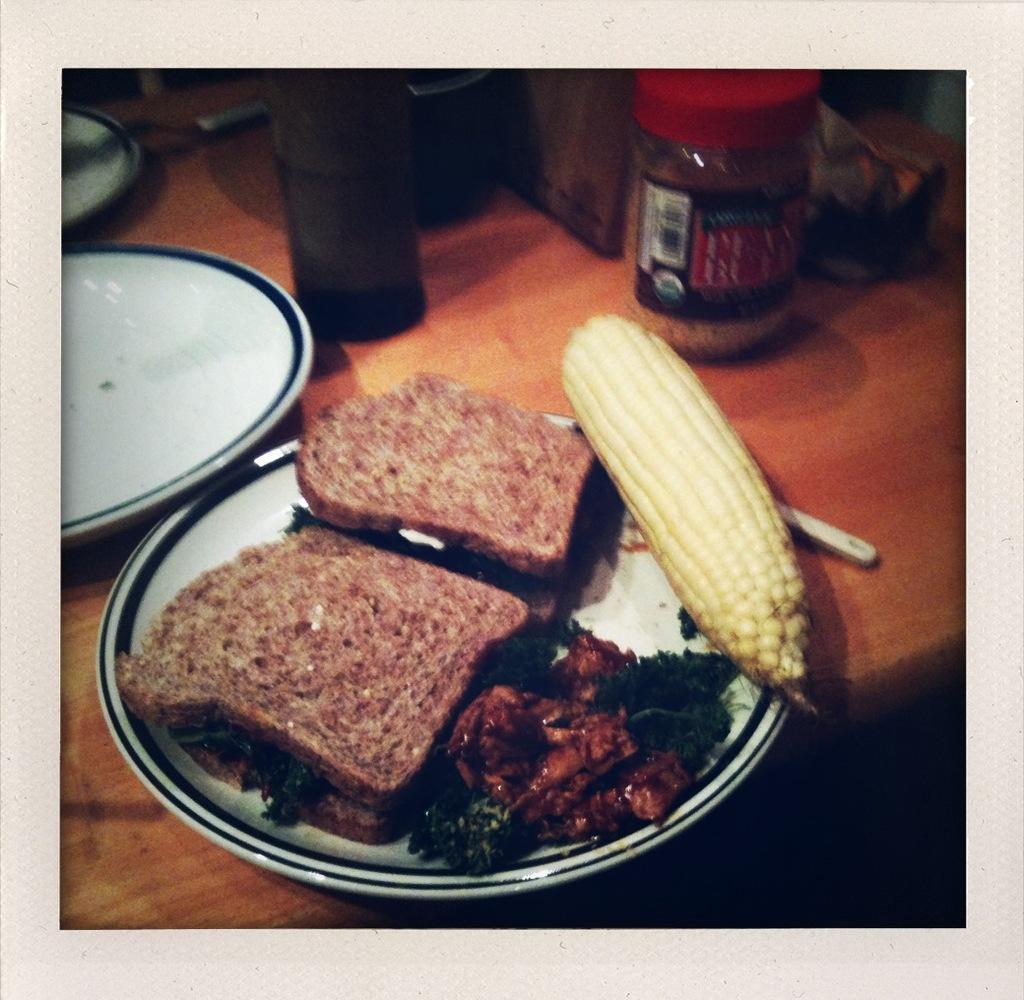Could you give a brief overview of what you see in this image? These are the bread slices in a white color plate and here it is a corn. 